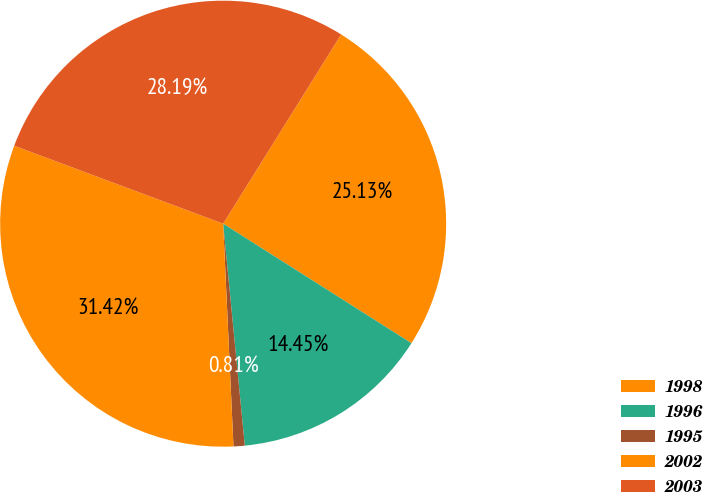<chart> <loc_0><loc_0><loc_500><loc_500><pie_chart><fcel>1998<fcel>1996<fcel>1995<fcel>2002<fcel>2003<nl><fcel>25.13%<fcel>14.45%<fcel>0.81%<fcel>31.42%<fcel>28.19%<nl></chart> 